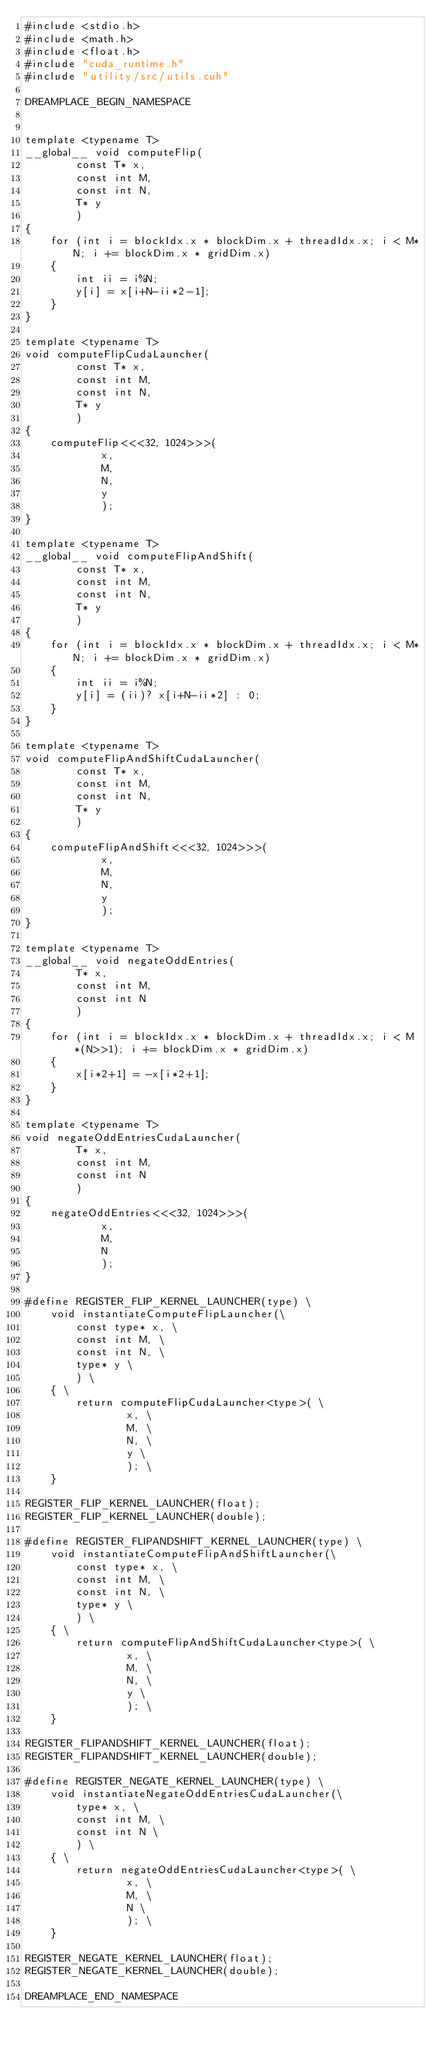Convert code to text. <code><loc_0><loc_0><loc_500><loc_500><_Cuda_>#include <stdio.h>
#include <math.h>
#include <float.h>
#include "cuda_runtime.h"
#include "utility/src/utils.cuh"

DREAMPLACE_BEGIN_NAMESPACE


template <typename T>
__global__ void computeFlip(
        const T* x, 
        const int M, 
        const int N, 
        T* y
        )
{
    for (int i = blockIdx.x * blockDim.x + threadIdx.x; i < M*N; i += blockDim.x * gridDim.x) 
    {
        int ii = i%N; 
        y[i] = x[i+N-ii*2-1];
    }
}

template <typename T>
void computeFlipCudaLauncher(
        const T* x, 
        const int M, 
        const int N, 
        T* y
        )
{
    computeFlip<<<32, 1024>>>(
            x, 
            M, 
            N, 
            y
            );
}

template <typename T>
__global__ void computeFlipAndShift(
        const T* x, 
        const int M, 
        const int N, 
        T* y
        )
{
    for (int i = blockIdx.x * blockDim.x + threadIdx.x; i < M*N; i += blockDim.x * gridDim.x) 
    {
        int ii = i%N; 
        y[i] = (ii)? x[i+N-ii*2] : 0;
    }
}

template <typename T>
void computeFlipAndShiftCudaLauncher(
        const T* x, 
        const int M, 
        const int N, 
        T* y
        )
{
    computeFlipAndShift<<<32, 1024>>>(
            x, 
            M, 
            N, 
            y
            );
}

template <typename T>
__global__ void negateOddEntries(
        T* x, 
        const int M, 
        const int N
        )
{
    for (int i = blockIdx.x * blockDim.x + threadIdx.x; i < M*(N>>1); i += blockDim.x * gridDim.x) 
    {
        x[i*2+1] = -x[i*2+1]; 
    }
}

template <typename T>
void negateOddEntriesCudaLauncher(
        T* x, 
        const int M, 
        const int N
        )
{
    negateOddEntries<<<32, 1024>>>(
            x, 
            M, 
            N
            );
}

#define REGISTER_FLIP_KERNEL_LAUNCHER(type) \
    void instantiateComputeFlipLauncher(\
        const type* x, \
        const int M, \
        const int N, \
        type* y \
        ) \
    { \
        return computeFlipCudaLauncher<type>( \
                x, \
                M, \
                N, \
                y \
                ); \
    }

REGISTER_FLIP_KERNEL_LAUNCHER(float);
REGISTER_FLIP_KERNEL_LAUNCHER(double);

#define REGISTER_FLIPANDSHIFT_KERNEL_LAUNCHER(type) \
    void instantiateComputeFlipAndShiftLauncher(\
        const type* x, \
        const int M, \
        const int N, \
        type* y \
        ) \
    { \
        return computeFlipAndShiftCudaLauncher<type>( \
                x, \
                M, \
                N, \
                y \
                ); \
    }

REGISTER_FLIPANDSHIFT_KERNEL_LAUNCHER(float);
REGISTER_FLIPANDSHIFT_KERNEL_LAUNCHER(double);

#define REGISTER_NEGATE_KERNEL_LAUNCHER(type) \
    void instantiateNegateOddEntriesCudaLauncher(\
        type* x, \
        const int M, \
        const int N \
        ) \
    { \
        return negateOddEntriesCudaLauncher<type>( \
                x, \
                M, \
                N \
                ); \
    }

REGISTER_NEGATE_KERNEL_LAUNCHER(float);
REGISTER_NEGATE_KERNEL_LAUNCHER(double);

DREAMPLACE_END_NAMESPACE
</code> 